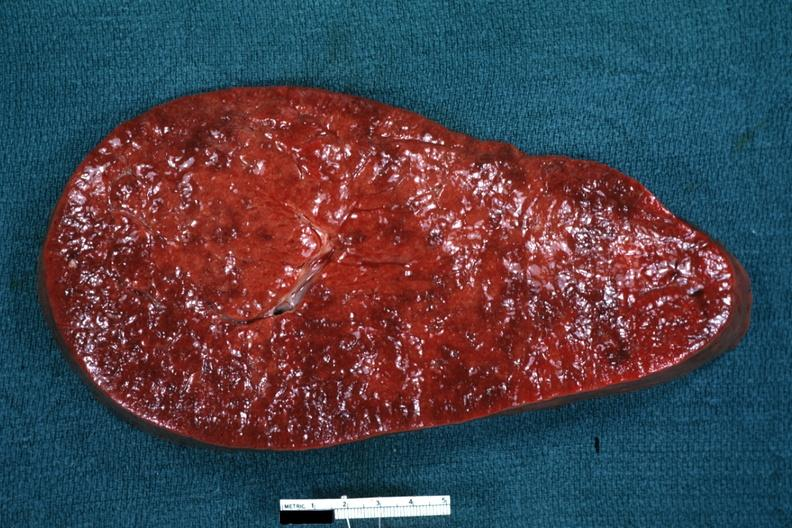what is present?
Answer the question using a single word or phrase. Hematologic 